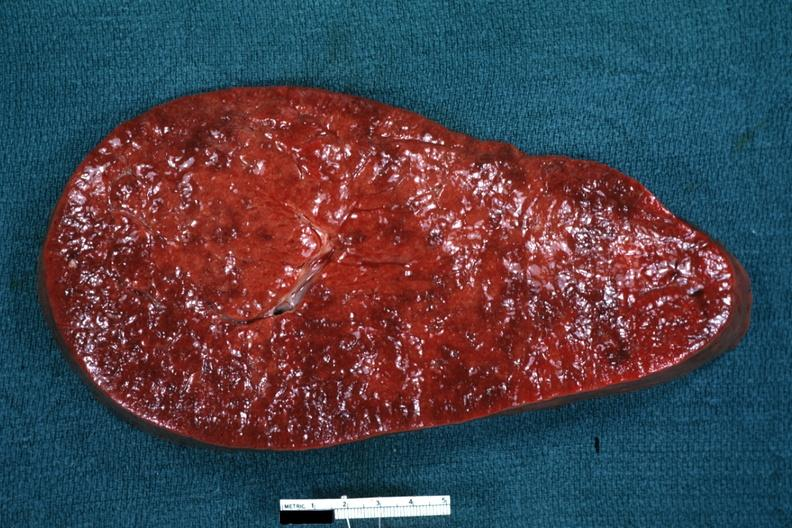what is present?
Answer the question using a single word or phrase. Hematologic 